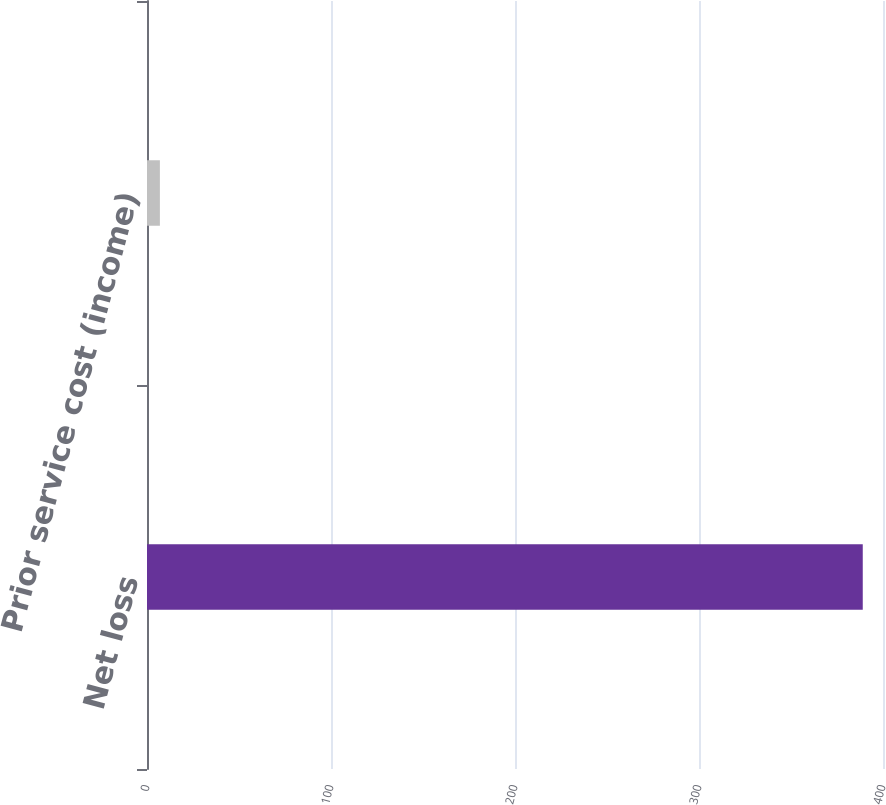Convert chart. <chart><loc_0><loc_0><loc_500><loc_500><bar_chart><fcel>Net loss<fcel>Prior service cost (income)<nl><fcel>389<fcel>7<nl></chart> 